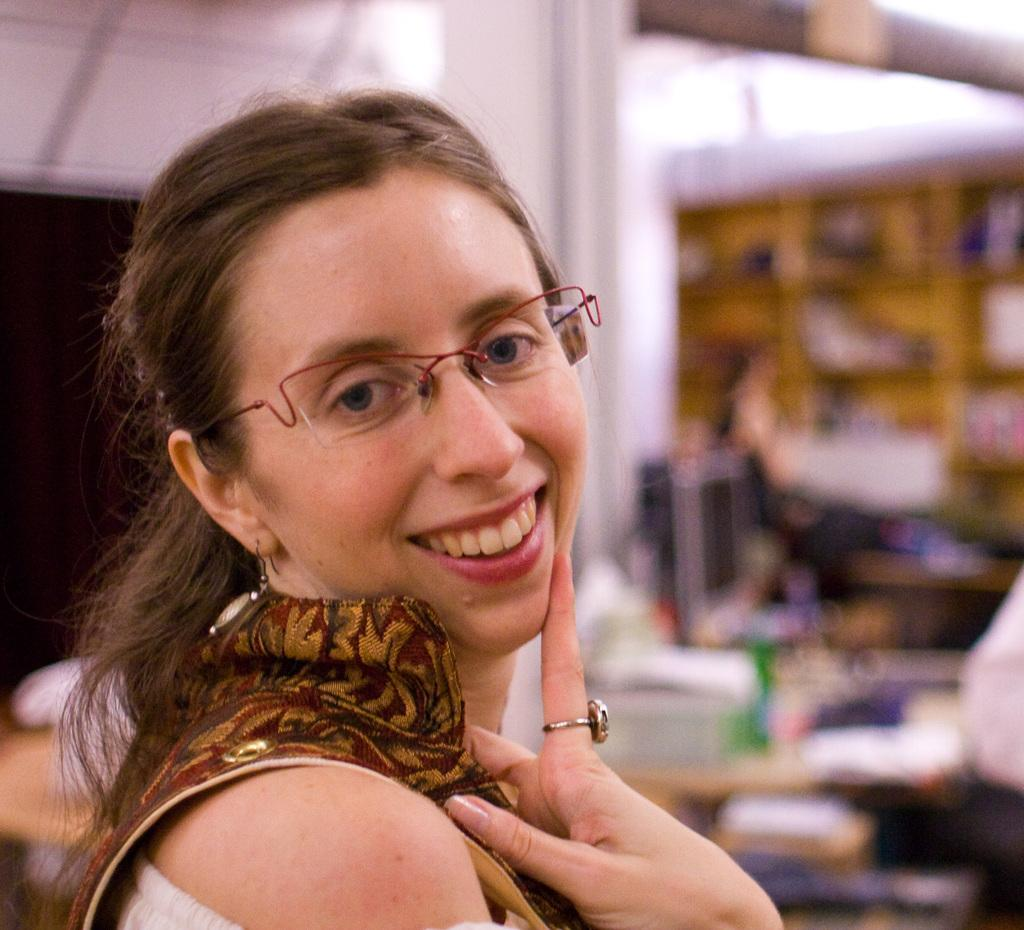Who is the main subject in the image? There is a lady in the center of the image. Can you describe the background of the image? The background of the image is blurry. What type of business does the lady own in the image? There is no information about a business in the image; it only shows a lady in the center and a blurry background. 